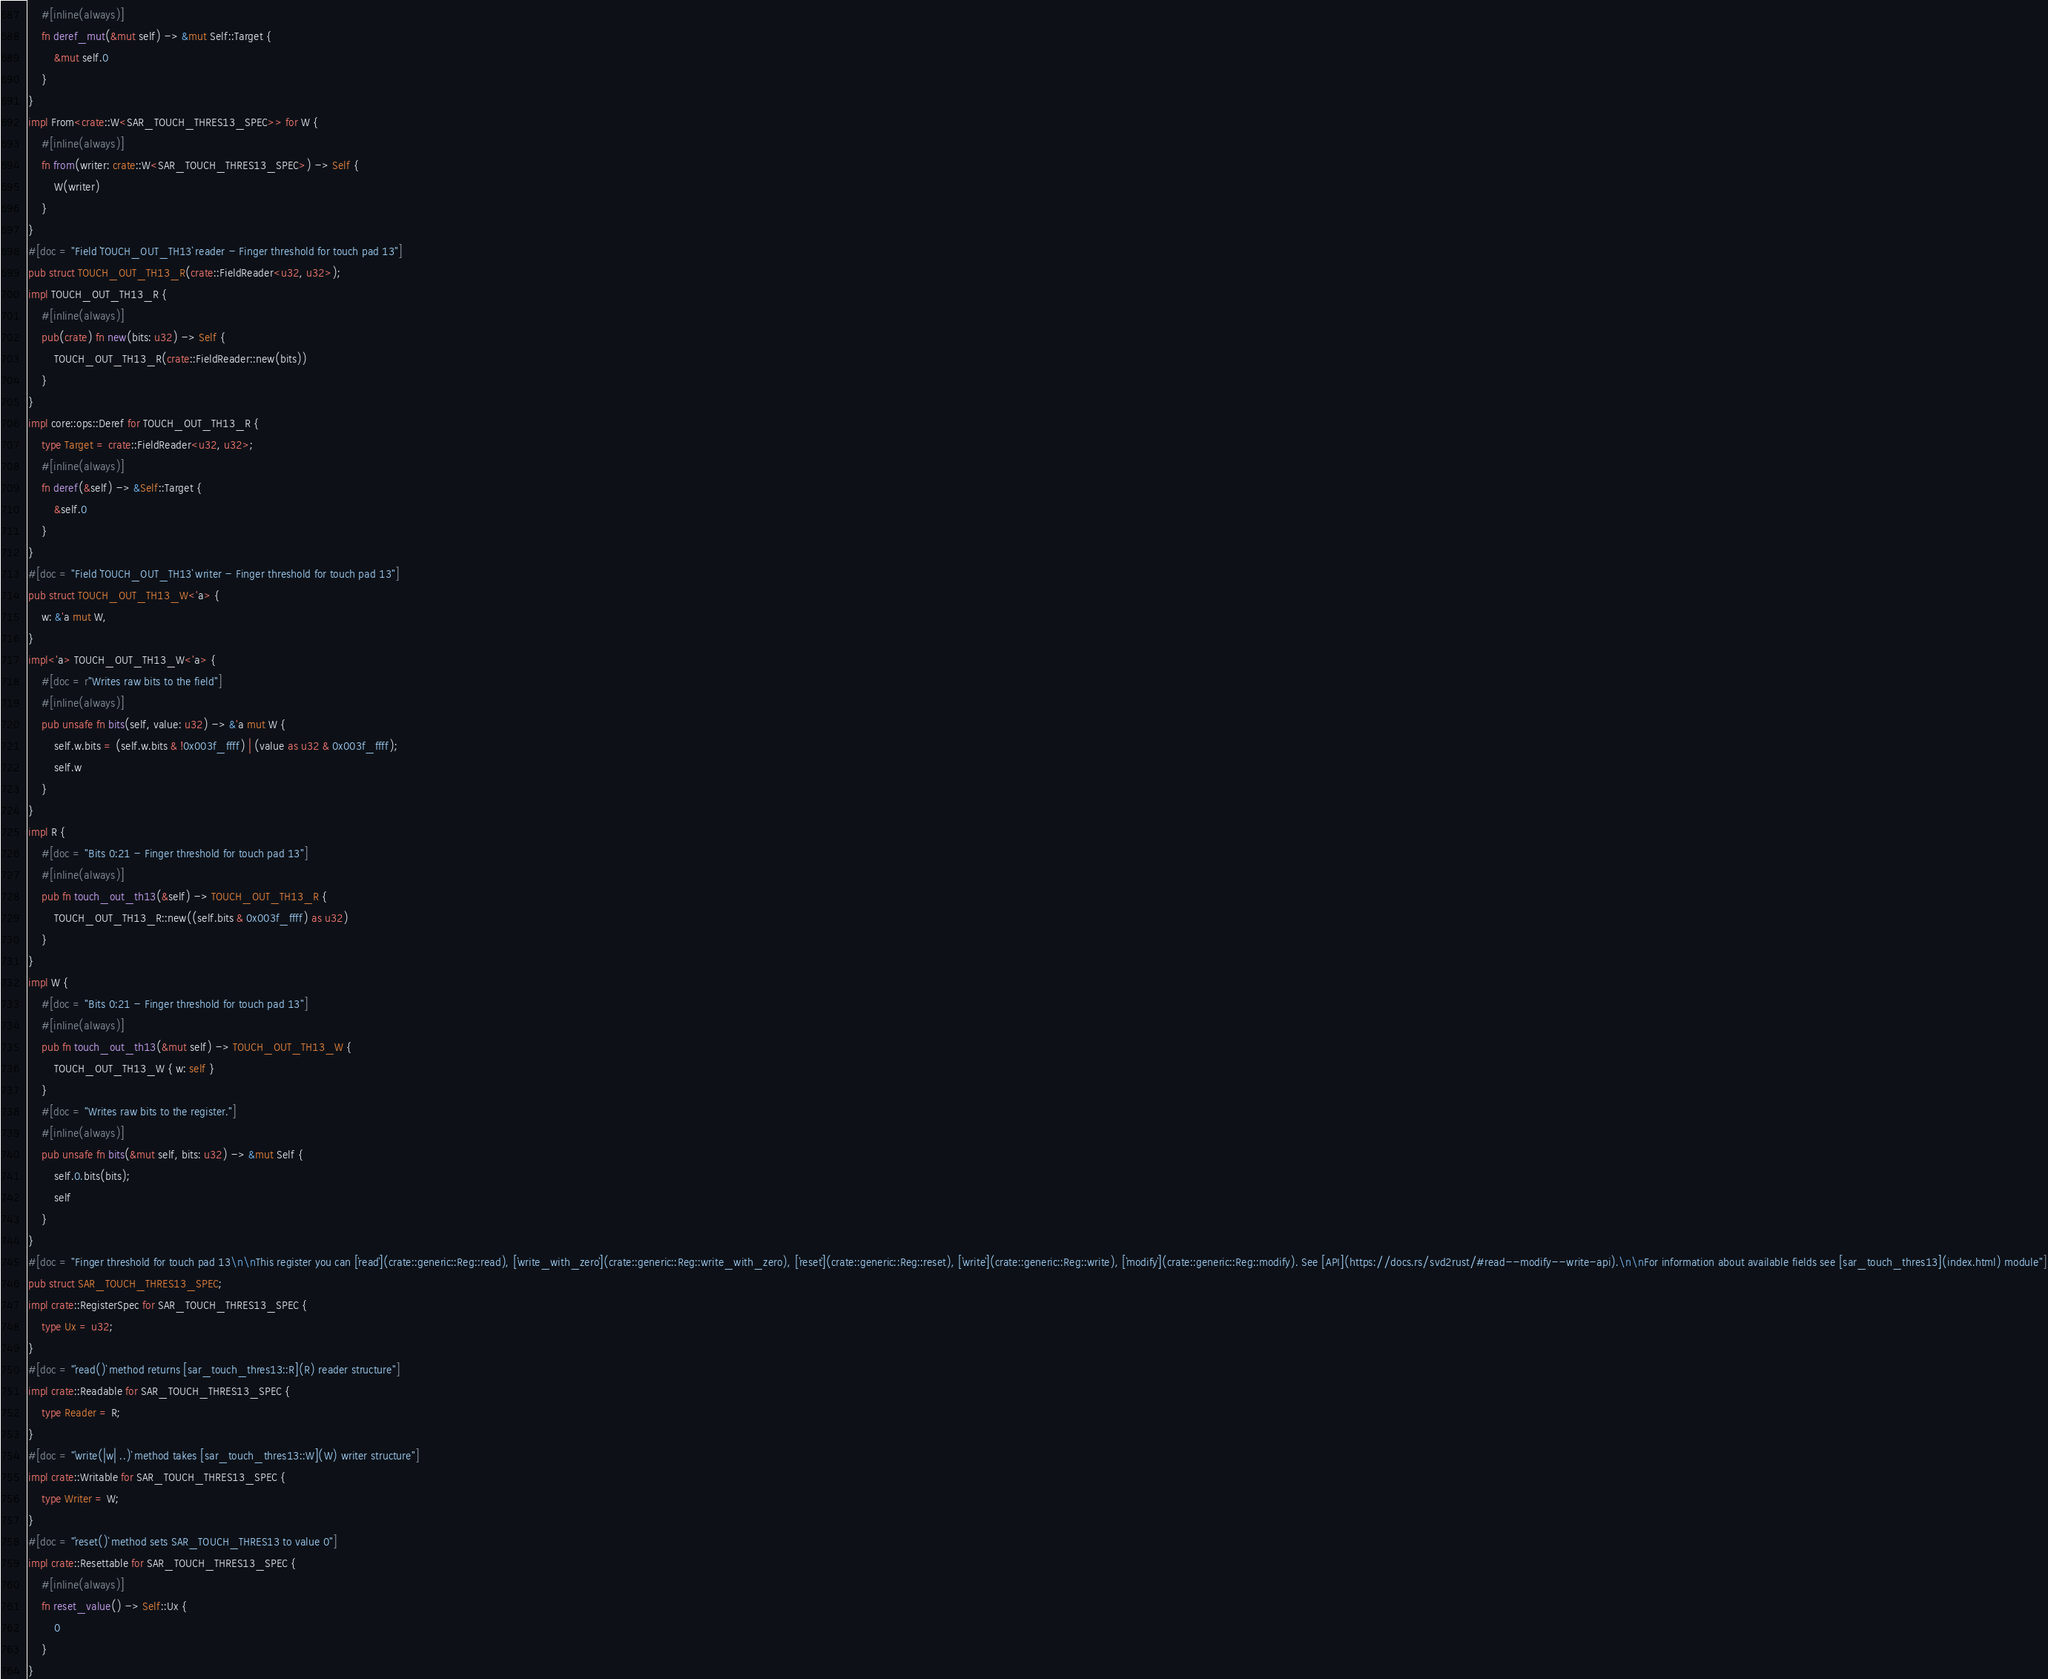Convert code to text. <code><loc_0><loc_0><loc_500><loc_500><_Rust_>    #[inline(always)]
    fn deref_mut(&mut self) -> &mut Self::Target {
        &mut self.0
    }
}
impl From<crate::W<SAR_TOUCH_THRES13_SPEC>> for W {
    #[inline(always)]
    fn from(writer: crate::W<SAR_TOUCH_THRES13_SPEC>) -> Self {
        W(writer)
    }
}
#[doc = "Field `TOUCH_OUT_TH13` reader - Finger threshold for touch pad 13"]
pub struct TOUCH_OUT_TH13_R(crate::FieldReader<u32, u32>);
impl TOUCH_OUT_TH13_R {
    #[inline(always)]
    pub(crate) fn new(bits: u32) -> Self {
        TOUCH_OUT_TH13_R(crate::FieldReader::new(bits))
    }
}
impl core::ops::Deref for TOUCH_OUT_TH13_R {
    type Target = crate::FieldReader<u32, u32>;
    #[inline(always)]
    fn deref(&self) -> &Self::Target {
        &self.0
    }
}
#[doc = "Field `TOUCH_OUT_TH13` writer - Finger threshold for touch pad 13"]
pub struct TOUCH_OUT_TH13_W<'a> {
    w: &'a mut W,
}
impl<'a> TOUCH_OUT_TH13_W<'a> {
    #[doc = r"Writes raw bits to the field"]
    #[inline(always)]
    pub unsafe fn bits(self, value: u32) -> &'a mut W {
        self.w.bits = (self.w.bits & !0x003f_ffff) | (value as u32 & 0x003f_ffff);
        self.w
    }
}
impl R {
    #[doc = "Bits 0:21 - Finger threshold for touch pad 13"]
    #[inline(always)]
    pub fn touch_out_th13(&self) -> TOUCH_OUT_TH13_R {
        TOUCH_OUT_TH13_R::new((self.bits & 0x003f_ffff) as u32)
    }
}
impl W {
    #[doc = "Bits 0:21 - Finger threshold for touch pad 13"]
    #[inline(always)]
    pub fn touch_out_th13(&mut self) -> TOUCH_OUT_TH13_W {
        TOUCH_OUT_TH13_W { w: self }
    }
    #[doc = "Writes raw bits to the register."]
    #[inline(always)]
    pub unsafe fn bits(&mut self, bits: u32) -> &mut Self {
        self.0.bits(bits);
        self
    }
}
#[doc = "Finger threshold for touch pad 13\n\nThis register you can [`read`](crate::generic::Reg::read), [`write_with_zero`](crate::generic::Reg::write_with_zero), [`reset`](crate::generic::Reg::reset), [`write`](crate::generic::Reg::write), [`modify`](crate::generic::Reg::modify). See [API](https://docs.rs/svd2rust/#read--modify--write-api).\n\nFor information about available fields see [sar_touch_thres13](index.html) module"]
pub struct SAR_TOUCH_THRES13_SPEC;
impl crate::RegisterSpec for SAR_TOUCH_THRES13_SPEC {
    type Ux = u32;
}
#[doc = "`read()` method returns [sar_touch_thres13::R](R) reader structure"]
impl crate::Readable for SAR_TOUCH_THRES13_SPEC {
    type Reader = R;
}
#[doc = "`write(|w| ..)` method takes [sar_touch_thres13::W](W) writer structure"]
impl crate::Writable for SAR_TOUCH_THRES13_SPEC {
    type Writer = W;
}
#[doc = "`reset()` method sets SAR_TOUCH_THRES13 to value 0"]
impl crate::Resettable for SAR_TOUCH_THRES13_SPEC {
    #[inline(always)]
    fn reset_value() -> Self::Ux {
        0
    }
}
</code> 